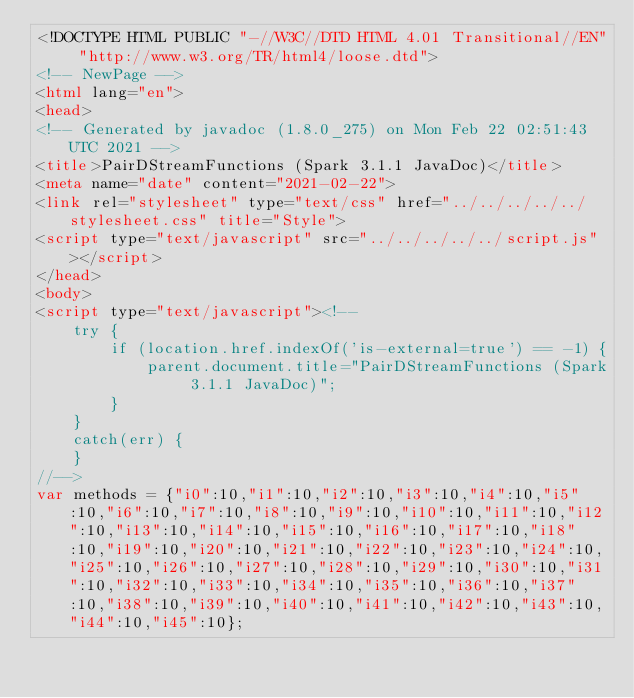Convert code to text. <code><loc_0><loc_0><loc_500><loc_500><_HTML_><!DOCTYPE HTML PUBLIC "-//W3C//DTD HTML 4.01 Transitional//EN" "http://www.w3.org/TR/html4/loose.dtd">
<!-- NewPage -->
<html lang="en">
<head>
<!-- Generated by javadoc (1.8.0_275) on Mon Feb 22 02:51:43 UTC 2021 -->
<title>PairDStreamFunctions (Spark 3.1.1 JavaDoc)</title>
<meta name="date" content="2021-02-22">
<link rel="stylesheet" type="text/css" href="../../../../../stylesheet.css" title="Style">
<script type="text/javascript" src="../../../../../script.js"></script>
</head>
<body>
<script type="text/javascript"><!--
    try {
        if (location.href.indexOf('is-external=true') == -1) {
            parent.document.title="PairDStreamFunctions (Spark 3.1.1 JavaDoc)";
        }
    }
    catch(err) {
    }
//-->
var methods = {"i0":10,"i1":10,"i2":10,"i3":10,"i4":10,"i5":10,"i6":10,"i7":10,"i8":10,"i9":10,"i10":10,"i11":10,"i12":10,"i13":10,"i14":10,"i15":10,"i16":10,"i17":10,"i18":10,"i19":10,"i20":10,"i21":10,"i22":10,"i23":10,"i24":10,"i25":10,"i26":10,"i27":10,"i28":10,"i29":10,"i30":10,"i31":10,"i32":10,"i33":10,"i34":10,"i35":10,"i36":10,"i37":10,"i38":10,"i39":10,"i40":10,"i41":10,"i42":10,"i43":10,"i44":10,"i45":10};</code> 